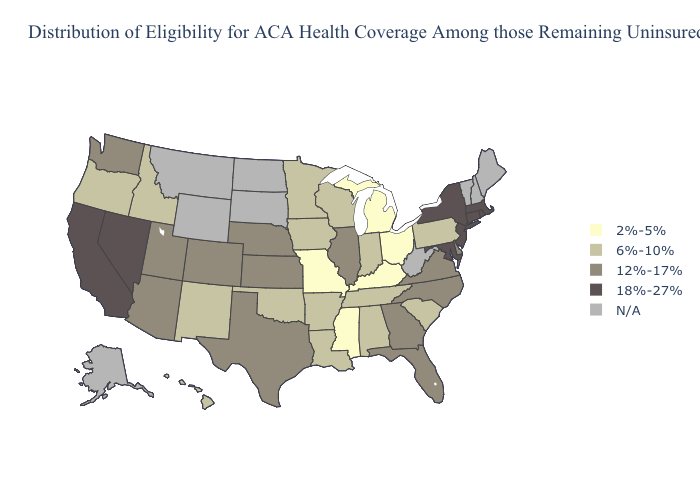Among the states that border Wyoming , which have the lowest value?
Quick response, please. Idaho. Which states hav the highest value in the MidWest?
Keep it brief. Illinois, Kansas, Nebraska. What is the value of Alaska?
Give a very brief answer. N/A. What is the lowest value in the Northeast?
Keep it brief. 6%-10%. What is the value of Nebraska?
Give a very brief answer. 12%-17%. What is the lowest value in states that border Virginia?
Keep it brief. 2%-5%. Does the map have missing data?
Keep it brief. Yes. Which states have the lowest value in the USA?
Concise answer only. Kentucky, Michigan, Mississippi, Missouri, Ohio. How many symbols are there in the legend?
Write a very short answer. 5. Which states hav the highest value in the Northeast?
Give a very brief answer. Connecticut, Massachusetts, New Jersey, New York, Rhode Island. Does Indiana have the lowest value in the MidWest?
Quick response, please. No. Name the states that have a value in the range 12%-17%?
Answer briefly. Arizona, Colorado, Delaware, Florida, Georgia, Illinois, Kansas, Nebraska, North Carolina, Texas, Utah, Virginia, Washington. Among the states that border New Jersey , does New York have the highest value?
Concise answer only. Yes. 